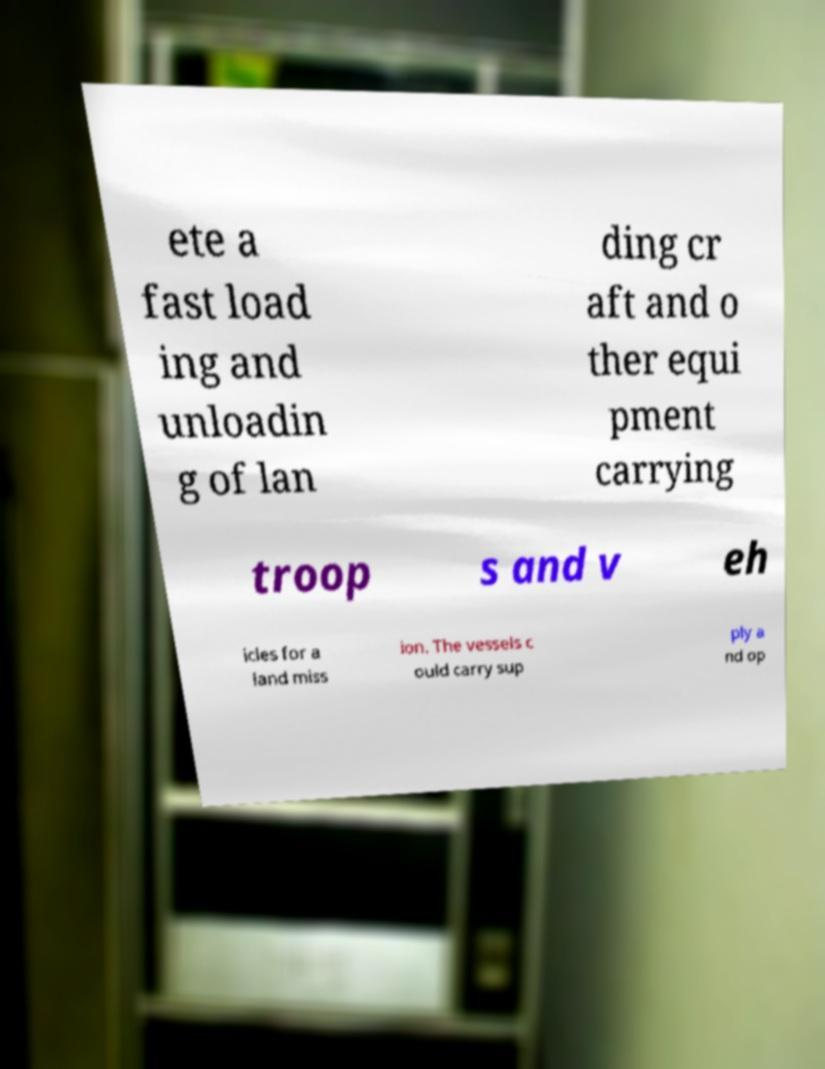Could you assist in decoding the text presented in this image and type it out clearly? ete a fast load ing and unloadin g of lan ding cr aft and o ther equi pment carrying troop s and v eh icles for a land miss ion. The vessels c ould carry sup ply a nd op 